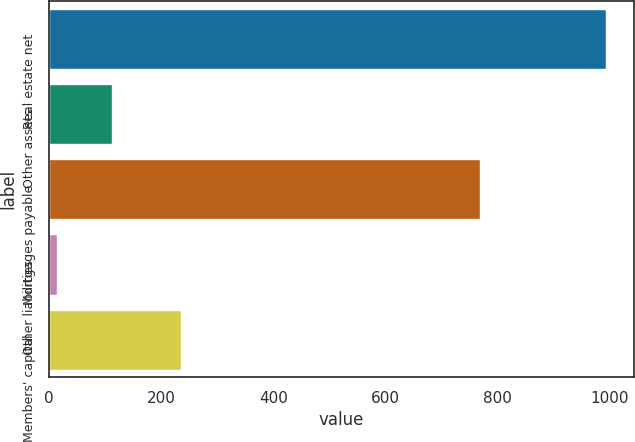Convert chart to OTSL. <chart><loc_0><loc_0><loc_500><loc_500><bar_chart><fcel>Real estate net<fcel>Other assets<fcel>Mortgages payable<fcel>Other liabilities<fcel>Members' capital<nl><fcel>993.5<fcel>111.95<fcel>767.8<fcel>14<fcel>236<nl></chart> 